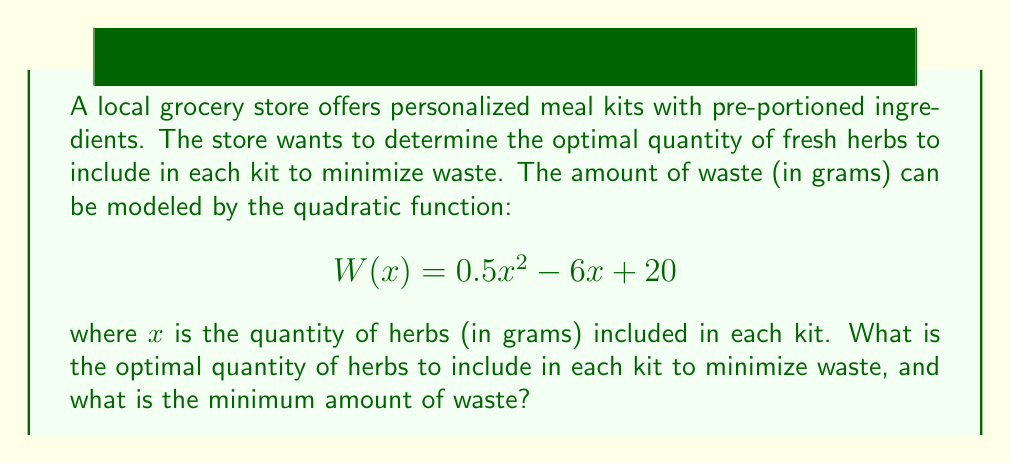Help me with this question. To solve this problem, we need to find the minimum point of the quadratic function. The steps are as follows:

1) The general form of a quadratic function is $f(x) = ax^2 + bx + c$. In this case:
   $a = 0.5$, $b = -6$, and $c = 20$

2) For a quadratic function, the x-coordinate of the vertex (which gives the optimal quantity) is calculated using the formula:
   $$x = -\frac{b}{2a}$$

3) Substituting our values:
   $$x = -\frac{-6}{2(0.5)} = \frac{6}{1} = 6$$

4) Therefore, the optimal quantity of herbs to include is 6 grams.

5) To find the minimum amount of waste, we substitute x = 6 into the original function:
   $$W(6) = 0.5(6)^2 - 6(6) + 20$$
   $$= 0.5(36) - 36 + 20$$
   $$= 18 - 36 + 20$$
   $$= 2$$

Thus, the minimum amount of waste is 2 grams.
Answer: The optimal quantity of herbs to include in each kit is 6 grams, and the minimum amount of waste is 2 grams. 